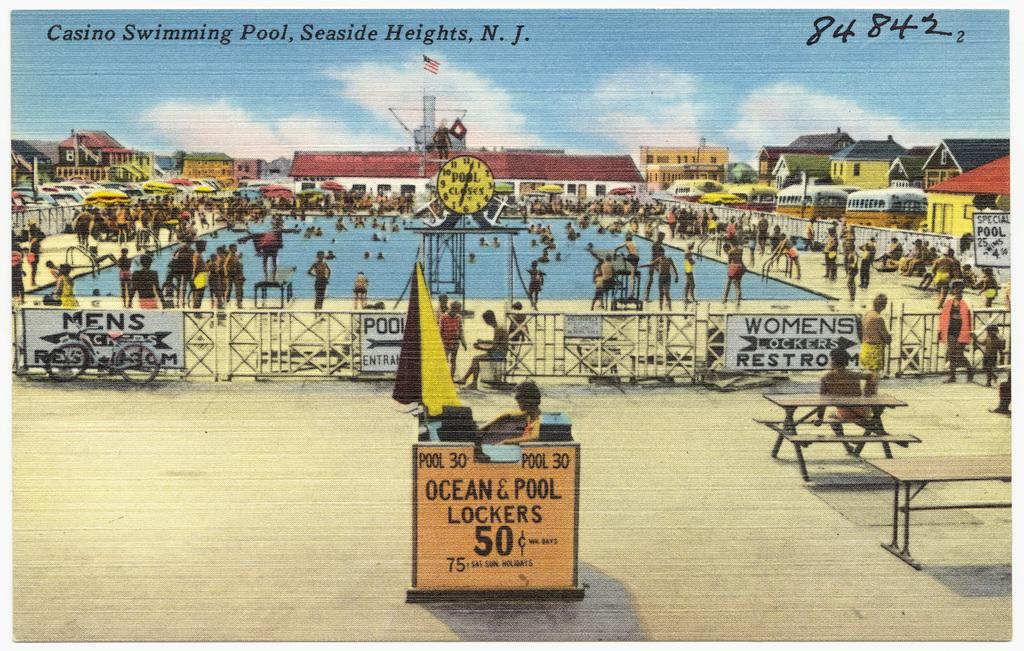<image>
Give a short and clear explanation of the subsequent image. A post card of the casino swimming pool in New Jersey. 